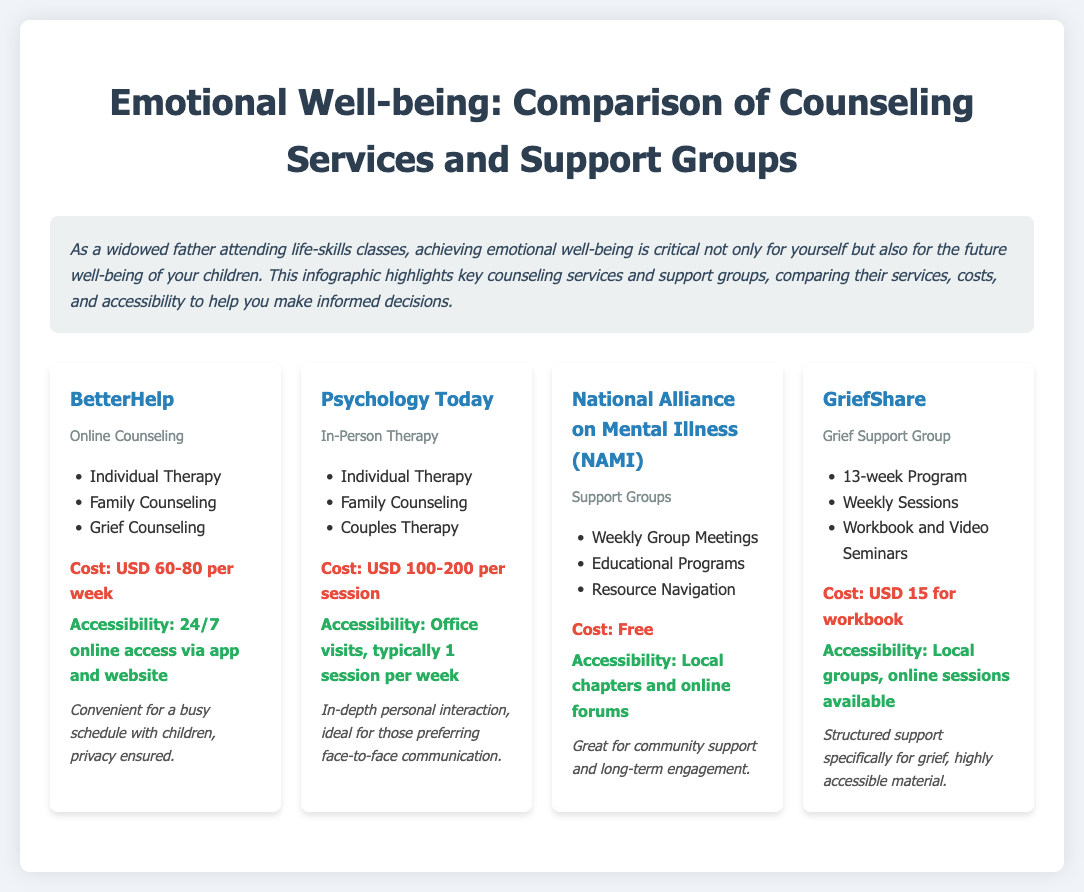What is the cost of BetterHelp? The cost of BetterHelp ranges from USD 60 to 80 per week according to the document.
Answer: USD 60-80 per week What types of therapy does Psychology Today offer? Psychology Today provides individual therapy, family counseling, and couples therapy as stated in the document.
Answer: Individual Therapy, Family Counseling, Couples Therapy Is National Alliance on Mental Illness (NAMI) a paid service? The document specifies that NAMI offers its services for free.
Answer: Free How often do GriefShare meetings occur? GriefShare runs a 13-week program with weekly sessions, as outlined in the infographic.
Answer: Weekly Which service provides 24/7 online access? The document mentions that BetterHelp offers 24/7 online access via an app and website.
Answer: BetterHelp What is the main focus of GriefShare? GriefShare is primarily a support group specifically for grief, based on the listed services.
Answer: Grief support Which counseling service is ideal for face-to-face interaction? According to the document, Psychology Today is ideal for those preferring face-to-face communication.
Answer: Psychology Today What is a key feature of NAMI? NAMI offers weekly group meetings along with educational programs as highlighted in the document.
Answer: Weekly Group Meetings Which service has the highest per-session cost? The document indicates that Psychology Today has a per-session cost of USD 100-200, making it the highest.
Answer: USD 100-200 per session 